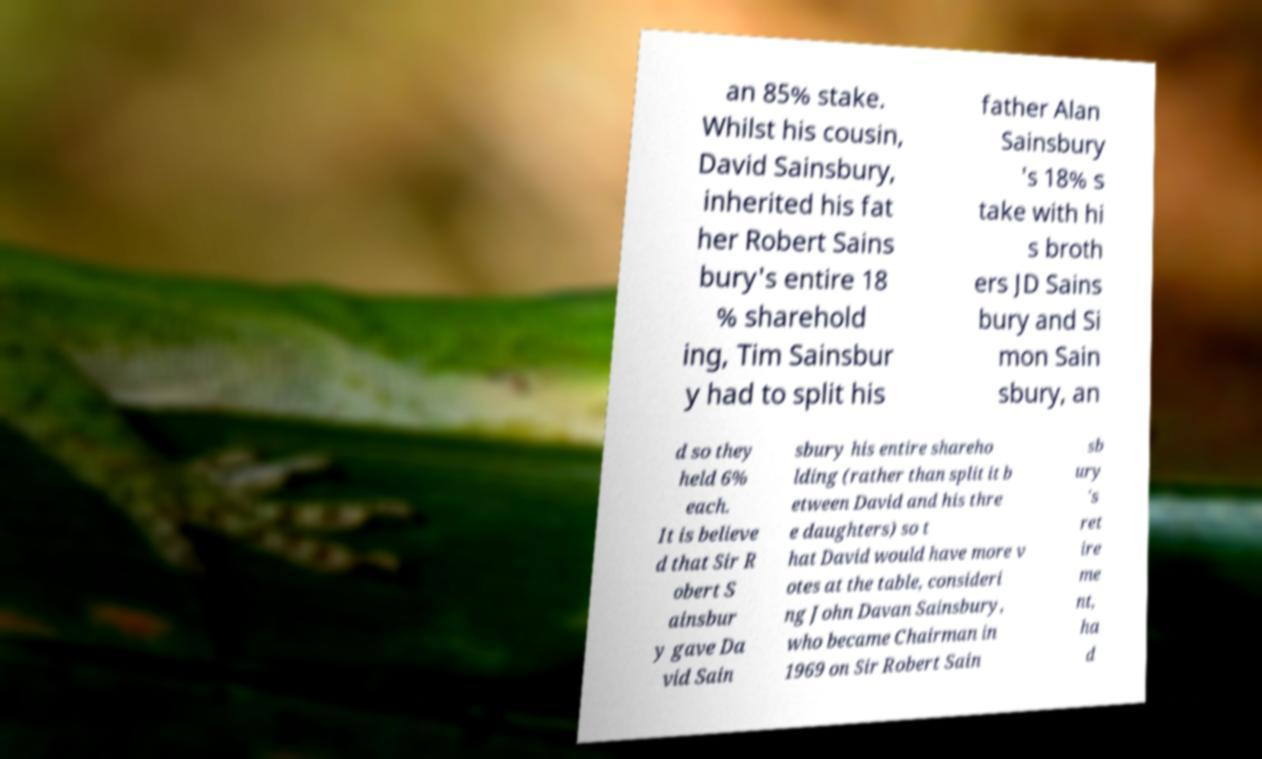I need the written content from this picture converted into text. Can you do that? an 85% stake. Whilst his cousin, David Sainsbury, inherited his fat her Robert Sains bury's entire 18 % sharehold ing, Tim Sainsbur y had to split his father Alan Sainsbury 's 18% s take with hi s broth ers JD Sains bury and Si mon Sain sbury, an d so they held 6% each. It is believe d that Sir R obert S ainsbur y gave Da vid Sain sbury his entire shareho lding (rather than split it b etween David and his thre e daughters) so t hat David would have more v otes at the table, consideri ng John Davan Sainsbury, who became Chairman in 1969 on Sir Robert Sain sb ury 's ret ire me nt, ha d 